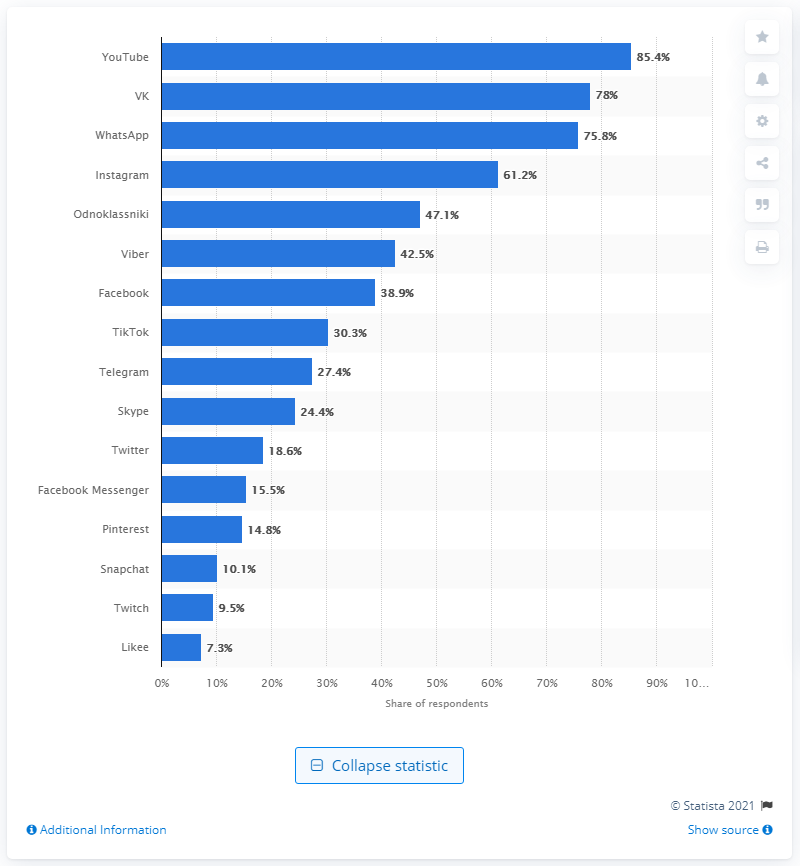Identify some key points in this picture. By the end of the third quarter of 2020, it is projected that approximately 85.4% of users will share information countrywide. 